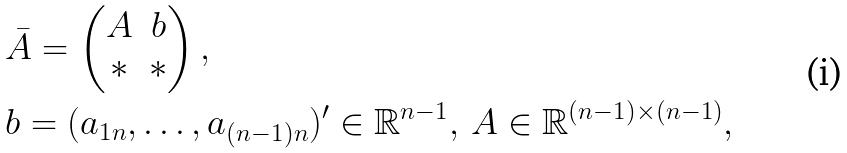<formula> <loc_0><loc_0><loc_500><loc_500>& \bar { A } = \begin{pmatrix} A & b \\ * & * \\ \end{pmatrix} , \\ & b = ( a _ { 1 n } , \dots , a _ { ( n - 1 ) n } ) ^ { \prime } \in \mathbb { R } ^ { n - 1 } , \, A \in \mathbb { R } ^ { ( n - 1 ) \times ( n - 1 ) } ,</formula> 